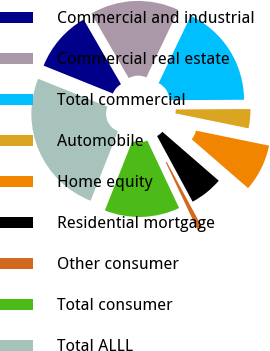<chart> <loc_0><loc_0><loc_500><loc_500><pie_chart><fcel>Commercial and industrial<fcel>Commercial real estate<fcel>Total commercial<fcel>Automobile<fcel>Home equity<fcel>Residential mortgage<fcel>Other consumer<fcel>Total consumer<fcel>Total ALLL<nl><fcel>10.57%<fcel>15.41%<fcel>17.84%<fcel>3.31%<fcel>8.15%<fcel>5.73%<fcel>0.89%<fcel>12.99%<fcel>25.1%<nl></chart> 